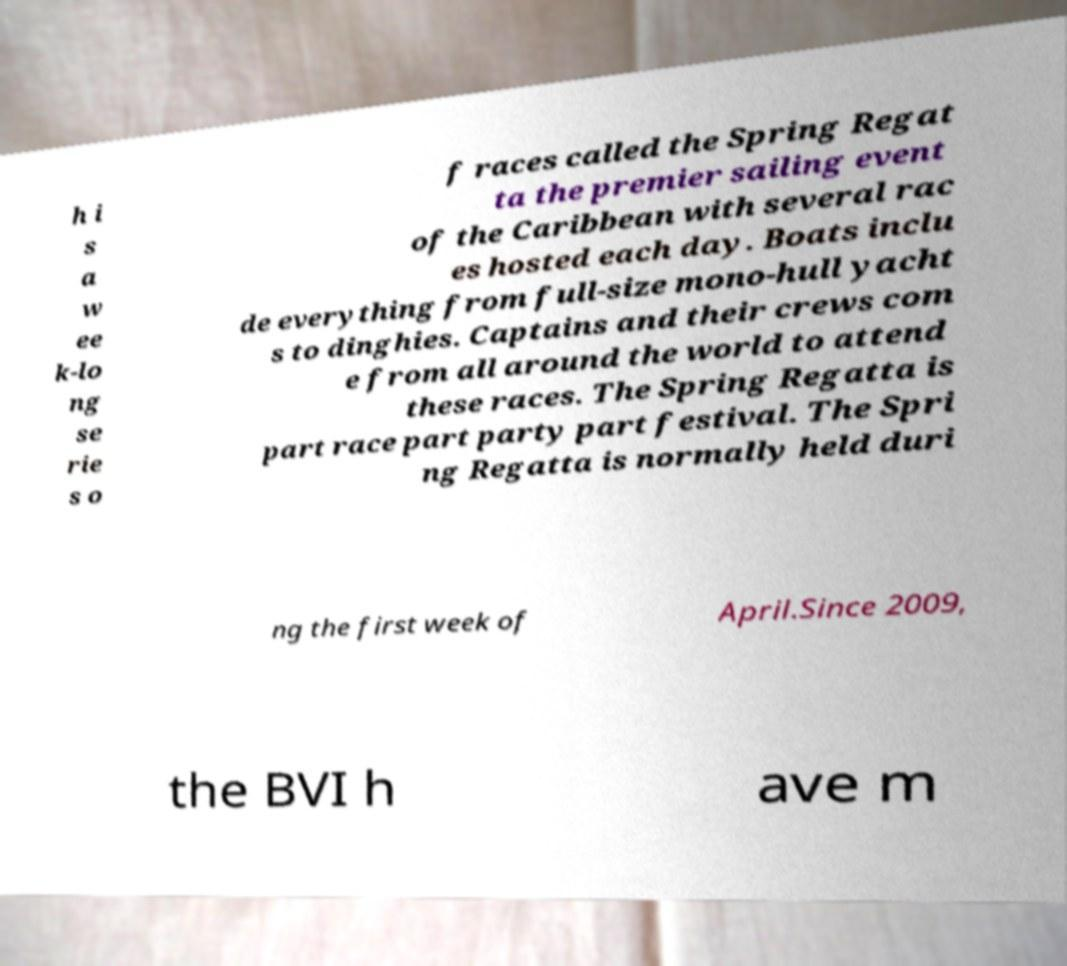Could you assist in decoding the text presented in this image and type it out clearly? h i s a w ee k-lo ng se rie s o f races called the Spring Regat ta the premier sailing event of the Caribbean with several rac es hosted each day. Boats inclu de everything from full-size mono-hull yacht s to dinghies. Captains and their crews com e from all around the world to attend these races. The Spring Regatta is part race part party part festival. The Spri ng Regatta is normally held duri ng the first week of April.Since 2009, the BVI h ave m 